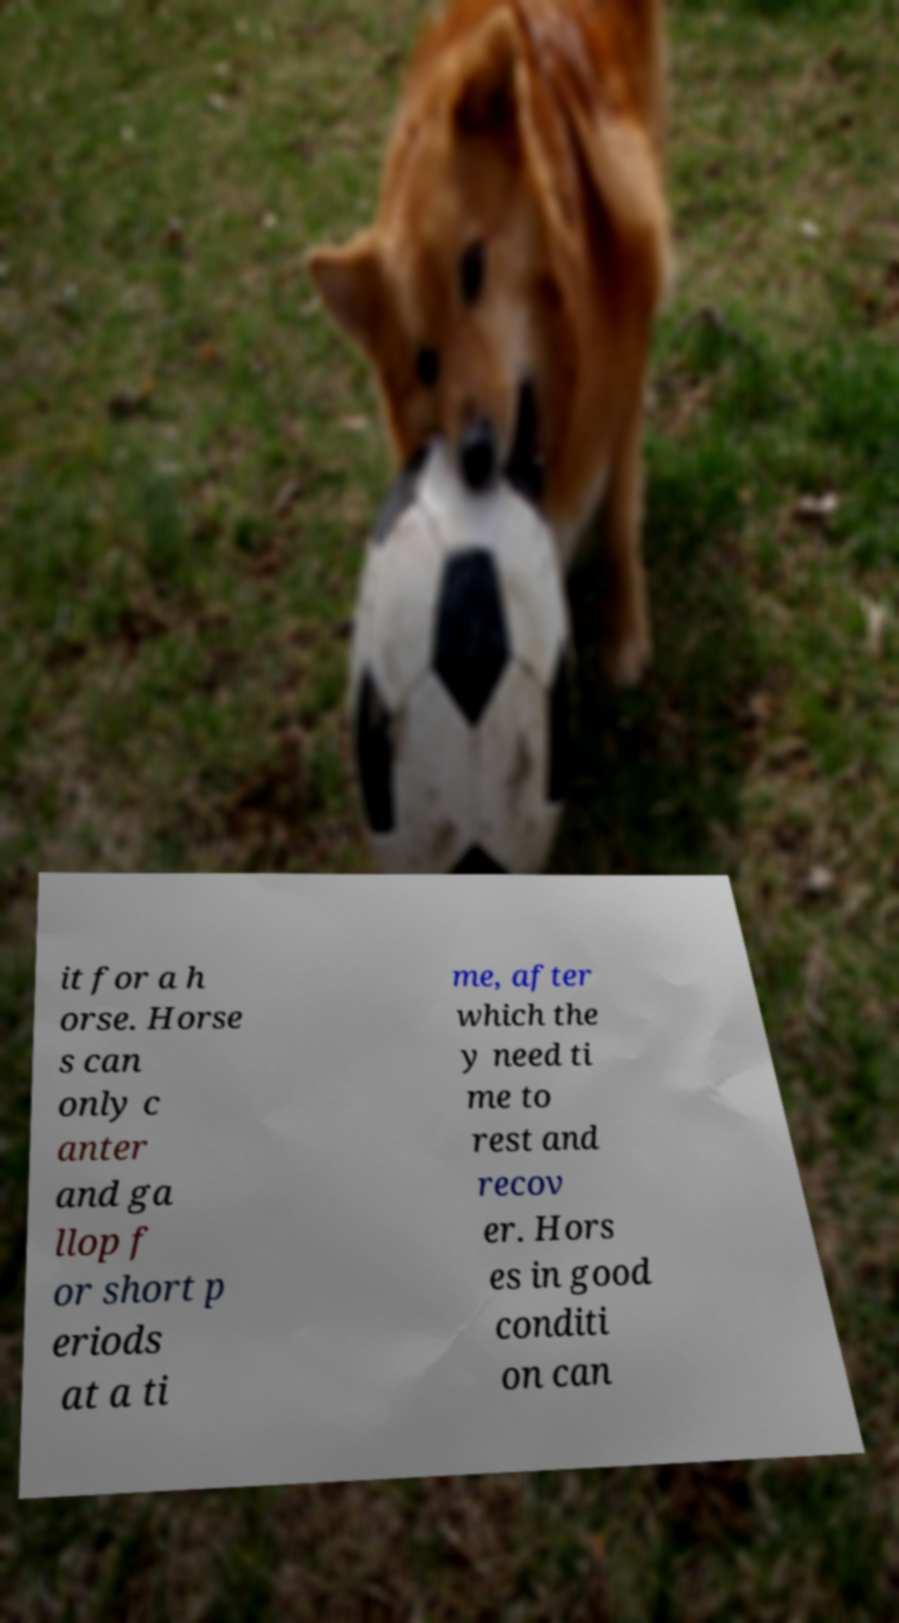Can you read and provide the text displayed in the image?This photo seems to have some interesting text. Can you extract and type it out for me? it for a h orse. Horse s can only c anter and ga llop f or short p eriods at a ti me, after which the y need ti me to rest and recov er. Hors es in good conditi on can 